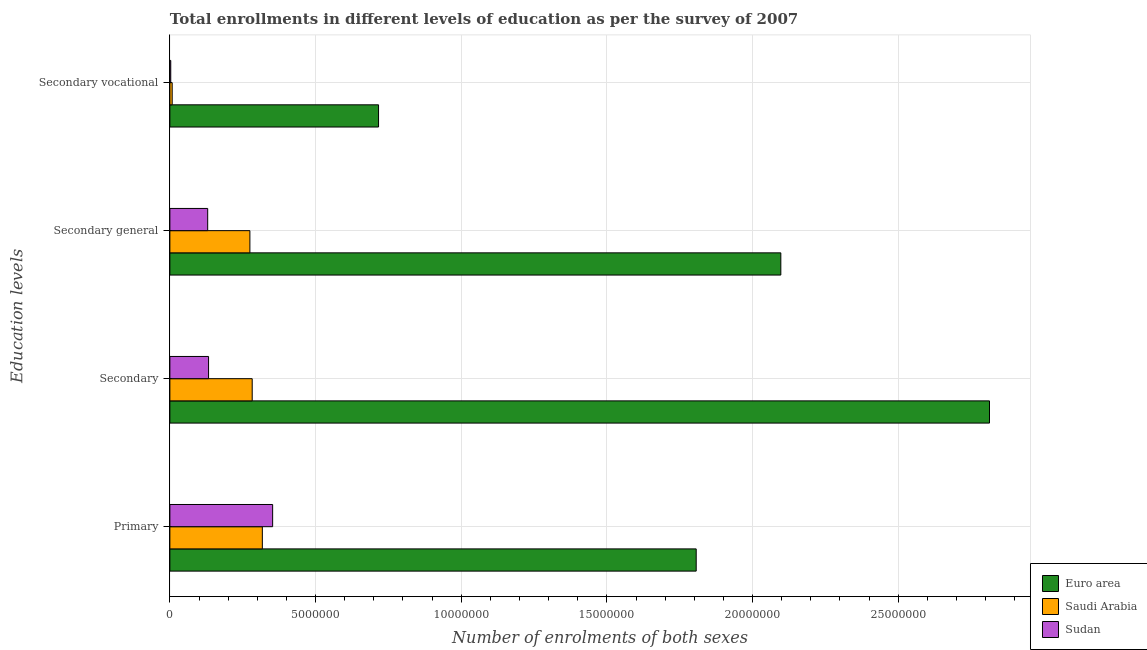How many different coloured bars are there?
Your response must be concise. 3. Are the number of bars per tick equal to the number of legend labels?
Ensure brevity in your answer.  Yes. What is the label of the 3rd group of bars from the top?
Offer a very short reply. Secondary. What is the number of enrolments in primary education in Sudan?
Provide a succinct answer. 3.53e+06. Across all countries, what is the maximum number of enrolments in secondary education?
Your answer should be compact. 2.81e+07. Across all countries, what is the minimum number of enrolments in secondary education?
Your response must be concise. 1.33e+06. In which country was the number of enrolments in primary education maximum?
Ensure brevity in your answer.  Euro area. In which country was the number of enrolments in secondary education minimum?
Your response must be concise. Sudan. What is the total number of enrolments in secondary education in the graph?
Offer a terse response. 3.23e+07. What is the difference between the number of enrolments in secondary general education in Euro area and that in Saudi Arabia?
Offer a very short reply. 1.82e+07. What is the difference between the number of enrolments in secondary general education in Saudi Arabia and the number of enrolments in primary education in Sudan?
Provide a succinct answer. -7.81e+05. What is the average number of enrolments in secondary vocational education per country?
Your answer should be very brief. 2.42e+06. What is the difference between the number of enrolments in secondary education and number of enrolments in secondary general education in Sudan?
Offer a very short reply. 3.03e+04. What is the ratio of the number of enrolments in secondary vocational education in Sudan to that in Saudi Arabia?
Provide a short and direct response. 0.38. Is the number of enrolments in secondary vocational education in Euro area less than that in Saudi Arabia?
Provide a succinct answer. No. What is the difference between the highest and the second highest number of enrolments in primary education?
Your answer should be compact. 1.45e+07. What is the difference between the highest and the lowest number of enrolments in secondary general education?
Make the answer very short. 1.97e+07. In how many countries, is the number of enrolments in secondary general education greater than the average number of enrolments in secondary general education taken over all countries?
Your answer should be compact. 1. Is the sum of the number of enrolments in secondary vocational education in Saudi Arabia and Euro area greater than the maximum number of enrolments in secondary general education across all countries?
Your response must be concise. No. Is it the case that in every country, the sum of the number of enrolments in secondary education and number of enrolments in secondary vocational education is greater than the sum of number of enrolments in primary education and number of enrolments in secondary general education?
Give a very brief answer. No. What does the 3rd bar from the top in Secondary represents?
Keep it short and to the point. Euro area. What does the 3rd bar from the bottom in Primary represents?
Offer a terse response. Sudan. Is it the case that in every country, the sum of the number of enrolments in primary education and number of enrolments in secondary education is greater than the number of enrolments in secondary general education?
Your response must be concise. Yes. Are all the bars in the graph horizontal?
Make the answer very short. Yes. What is the difference between two consecutive major ticks on the X-axis?
Your answer should be very brief. 5.00e+06. Are the values on the major ticks of X-axis written in scientific E-notation?
Offer a very short reply. No. Where does the legend appear in the graph?
Offer a terse response. Bottom right. How many legend labels are there?
Offer a very short reply. 3. How are the legend labels stacked?
Offer a terse response. Vertical. What is the title of the graph?
Provide a short and direct response. Total enrollments in different levels of education as per the survey of 2007. Does "Sweden" appear as one of the legend labels in the graph?
Keep it short and to the point. No. What is the label or title of the X-axis?
Ensure brevity in your answer.  Number of enrolments of both sexes. What is the label or title of the Y-axis?
Offer a terse response. Education levels. What is the Number of enrolments of both sexes in Euro area in Primary?
Offer a very short reply. 1.81e+07. What is the Number of enrolments of both sexes in Saudi Arabia in Primary?
Provide a short and direct response. 3.17e+06. What is the Number of enrolments of both sexes in Sudan in Primary?
Provide a short and direct response. 3.53e+06. What is the Number of enrolments of both sexes of Euro area in Secondary?
Your response must be concise. 2.81e+07. What is the Number of enrolments of both sexes in Saudi Arabia in Secondary?
Ensure brevity in your answer.  2.83e+06. What is the Number of enrolments of both sexes in Sudan in Secondary?
Ensure brevity in your answer.  1.33e+06. What is the Number of enrolments of both sexes of Euro area in Secondary general?
Ensure brevity in your answer.  2.10e+07. What is the Number of enrolments of both sexes of Saudi Arabia in Secondary general?
Your answer should be compact. 2.75e+06. What is the Number of enrolments of both sexes of Sudan in Secondary general?
Provide a short and direct response. 1.30e+06. What is the Number of enrolments of both sexes in Euro area in Secondary vocational?
Make the answer very short. 7.16e+06. What is the Number of enrolments of both sexes in Saudi Arabia in Secondary vocational?
Ensure brevity in your answer.  7.96e+04. What is the Number of enrolments of both sexes of Sudan in Secondary vocational?
Ensure brevity in your answer.  3.03e+04. Across all Education levels, what is the maximum Number of enrolments of both sexes of Euro area?
Your answer should be compact. 2.81e+07. Across all Education levels, what is the maximum Number of enrolments of both sexes in Saudi Arabia?
Ensure brevity in your answer.  3.17e+06. Across all Education levels, what is the maximum Number of enrolments of both sexes in Sudan?
Keep it short and to the point. 3.53e+06. Across all Education levels, what is the minimum Number of enrolments of both sexes of Euro area?
Ensure brevity in your answer.  7.16e+06. Across all Education levels, what is the minimum Number of enrolments of both sexes in Saudi Arabia?
Keep it short and to the point. 7.96e+04. Across all Education levels, what is the minimum Number of enrolments of both sexes in Sudan?
Provide a short and direct response. 3.03e+04. What is the total Number of enrolments of both sexes of Euro area in the graph?
Offer a very short reply. 7.43e+07. What is the total Number of enrolments of both sexes in Saudi Arabia in the graph?
Provide a succinct answer. 8.83e+06. What is the total Number of enrolments of both sexes in Sudan in the graph?
Your answer should be very brief. 6.18e+06. What is the difference between the Number of enrolments of both sexes in Euro area in Primary and that in Secondary?
Give a very brief answer. -1.01e+07. What is the difference between the Number of enrolments of both sexes in Saudi Arabia in Primary and that in Secondary?
Your answer should be very brief. 3.48e+05. What is the difference between the Number of enrolments of both sexes of Sudan in Primary and that in Secondary?
Offer a terse response. 2.20e+06. What is the difference between the Number of enrolments of both sexes in Euro area in Primary and that in Secondary general?
Make the answer very short. -2.90e+06. What is the difference between the Number of enrolments of both sexes in Saudi Arabia in Primary and that in Secondary general?
Give a very brief answer. 4.27e+05. What is the difference between the Number of enrolments of both sexes in Sudan in Primary and that in Secondary general?
Your answer should be compact. 2.23e+06. What is the difference between the Number of enrolments of both sexes in Euro area in Primary and that in Secondary vocational?
Your answer should be compact. 1.09e+07. What is the difference between the Number of enrolments of both sexes of Saudi Arabia in Primary and that in Secondary vocational?
Your answer should be very brief. 3.09e+06. What is the difference between the Number of enrolments of both sexes of Sudan in Primary and that in Secondary vocational?
Provide a succinct answer. 3.50e+06. What is the difference between the Number of enrolments of both sexes of Euro area in Secondary and that in Secondary general?
Your answer should be very brief. 7.16e+06. What is the difference between the Number of enrolments of both sexes in Saudi Arabia in Secondary and that in Secondary general?
Your response must be concise. 7.96e+04. What is the difference between the Number of enrolments of both sexes of Sudan in Secondary and that in Secondary general?
Provide a short and direct response. 3.03e+04. What is the difference between the Number of enrolments of both sexes of Euro area in Secondary and that in Secondary vocational?
Keep it short and to the point. 2.10e+07. What is the difference between the Number of enrolments of both sexes of Saudi Arabia in Secondary and that in Secondary vocational?
Your answer should be very brief. 2.75e+06. What is the difference between the Number of enrolments of both sexes in Sudan in Secondary and that in Secondary vocational?
Give a very brief answer. 1.30e+06. What is the difference between the Number of enrolments of both sexes in Euro area in Secondary general and that in Secondary vocational?
Offer a terse response. 1.38e+07. What is the difference between the Number of enrolments of both sexes of Saudi Arabia in Secondary general and that in Secondary vocational?
Ensure brevity in your answer.  2.67e+06. What is the difference between the Number of enrolments of both sexes of Sudan in Secondary general and that in Secondary vocational?
Your answer should be compact. 1.27e+06. What is the difference between the Number of enrolments of both sexes of Euro area in Primary and the Number of enrolments of both sexes of Saudi Arabia in Secondary?
Your answer should be compact. 1.52e+07. What is the difference between the Number of enrolments of both sexes of Euro area in Primary and the Number of enrolments of both sexes of Sudan in Secondary?
Your answer should be very brief. 1.67e+07. What is the difference between the Number of enrolments of both sexes in Saudi Arabia in Primary and the Number of enrolments of both sexes in Sudan in Secondary?
Offer a very short reply. 1.85e+06. What is the difference between the Number of enrolments of both sexes of Euro area in Primary and the Number of enrolments of both sexes of Saudi Arabia in Secondary general?
Provide a succinct answer. 1.53e+07. What is the difference between the Number of enrolments of both sexes in Euro area in Primary and the Number of enrolments of both sexes in Sudan in Secondary general?
Your answer should be compact. 1.68e+07. What is the difference between the Number of enrolments of both sexes in Saudi Arabia in Primary and the Number of enrolments of both sexes in Sudan in Secondary general?
Provide a short and direct response. 1.88e+06. What is the difference between the Number of enrolments of both sexes in Euro area in Primary and the Number of enrolments of both sexes in Saudi Arabia in Secondary vocational?
Keep it short and to the point. 1.80e+07. What is the difference between the Number of enrolments of both sexes in Euro area in Primary and the Number of enrolments of both sexes in Sudan in Secondary vocational?
Ensure brevity in your answer.  1.80e+07. What is the difference between the Number of enrolments of both sexes of Saudi Arabia in Primary and the Number of enrolments of both sexes of Sudan in Secondary vocational?
Ensure brevity in your answer.  3.14e+06. What is the difference between the Number of enrolments of both sexes of Euro area in Secondary and the Number of enrolments of both sexes of Saudi Arabia in Secondary general?
Your response must be concise. 2.54e+07. What is the difference between the Number of enrolments of both sexes of Euro area in Secondary and the Number of enrolments of both sexes of Sudan in Secondary general?
Your response must be concise. 2.68e+07. What is the difference between the Number of enrolments of both sexes in Saudi Arabia in Secondary and the Number of enrolments of both sexes in Sudan in Secondary general?
Offer a terse response. 1.53e+06. What is the difference between the Number of enrolments of both sexes of Euro area in Secondary and the Number of enrolments of both sexes of Saudi Arabia in Secondary vocational?
Make the answer very short. 2.81e+07. What is the difference between the Number of enrolments of both sexes in Euro area in Secondary and the Number of enrolments of both sexes in Sudan in Secondary vocational?
Your response must be concise. 2.81e+07. What is the difference between the Number of enrolments of both sexes of Saudi Arabia in Secondary and the Number of enrolments of both sexes of Sudan in Secondary vocational?
Keep it short and to the point. 2.80e+06. What is the difference between the Number of enrolments of both sexes of Euro area in Secondary general and the Number of enrolments of both sexes of Saudi Arabia in Secondary vocational?
Your answer should be compact. 2.09e+07. What is the difference between the Number of enrolments of both sexes in Euro area in Secondary general and the Number of enrolments of both sexes in Sudan in Secondary vocational?
Ensure brevity in your answer.  2.09e+07. What is the difference between the Number of enrolments of both sexes in Saudi Arabia in Secondary general and the Number of enrolments of both sexes in Sudan in Secondary vocational?
Provide a short and direct response. 2.72e+06. What is the average Number of enrolments of both sexes in Euro area per Education levels?
Offer a terse response. 1.86e+07. What is the average Number of enrolments of both sexes in Saudi Arabia per Education levels?
Make the answer very short. 2.21e+06. What is the average Number of enrolments of both sexes of Sudan per Education levels?
Your response must be concise. 1.55e+06. What is the difference between the Number of enrolments of both sexes of Euro area and Number of enrolments of both sexes of Saudi Arabia in Primary?
Offer a very short reply. 1.49e+07. What is the difference between the Number of enrolments of both sexes in Euro area and Number of enrolments of both sexes in Sudan in Primary?
Your response must be concise. 1.45e+07. What is the difference between the Number of enrolments of both sexes in Saudi Arabia and Number of enrolments of both sexes in Sudan in Primary?
Offer a terse response. -3.54e+05. What is the difference between the Number of enrolments of both sexes of Euro area and Number of enrolments of both sexes of Saudi Arabia in Secondary?
Provide a succinct answer. 2.53e+07. What is the difference between the Number of enrolments of both sexes in Euro area and Number of enrolments of both sexes in Sudan in Secondary?
Make the answer very short. 2.68e+07. What is the difference between the Number of enrolments of both sexes in Saudi Arabia and Number of enrolments of both sexes in Sudan in Secondary?
Your response must be concise. 1.50e+06. What is the difference between the Number of enrolments of both sexes of Euro area and Number of enrolments of both sexes of Saudi Arabia in Secondary general?
Your answer should be compact. 1.82e+07. What is the difference between the Number of enrolments of both sexes in Euro area and Number of enrolments of both sexes in Sudan in Secondary general?
Your response must be concise. 1.97e+07. What is the difference between the Number of enrolments of both sexes in Saudi Arabia and Number of enrolments of both sexes in Sudan in Secondary general?
Your answer should be compact. 1.45e+06. What is the difference between the Number of enrolments of both sexes of Euro area and Number of enrolments of both sexes of Saudi Arabia in Secondary vocational?
Give a very brief answer. 7.08e+06. What is the difference between the Number of enrolments of both sexes of Euro area and Number of enrolments of both sexes of Sudan in Secondary vocational?
Provide a short and direct response. 7.13e+06. What is the difference between the Number of enrolments of both sexes of Saudi Arabia and Number of enrolments of both sexes of Sudan in Secondary vocational?
Give a very brief answer. 4.93e+04. What is the ratio of the Number of enrolments of both sexes of Euro area in Primary to that in Secondary?
Your answer should be compact. 0.64. What is the ratio of the Number of enrolments of both sexes of Saudi Arabia in Primary to that in Secondary?
Make the answer very short. 1.12. What is the ratio of the Number of enrolments of both sexes of Sudan in Primary to that in Secondary?
Make the answer very short. 2.66. What is the ratio of the Number of enrolments of both sexes of Euro area in Primary to that in Secondary general?
Your answer should be compact. 0.86. What is the ratio of the Number of enrolments of both sexes in Saudi Arabia in Primary to that in Secondary general?
Offer a terse response. 1.16. What is the ratio of the Number of enrolments of both sexes in Sudan in Primary to that in Secondary general?
Ensure brevity in your answer.  2.72. What is the ratio of the Number of enrolments of both sexes in Euro area in Primary to that in Secondary vocational?
Your answer should be compact. 2.52. What is the ratio of the Number of enrolments of both sexes of Saudi Arabia in Primary to that in Secondary vocational?
Your response must be concise. 39.87. What is the ratio of the Number of enrolments of both sexes in Sudan in Primary to that in Secondary vocational?
Give a very brief answer. 116.55. What is the ratio of the Number of enrolments of both sexes of Euro area in Secondary to that in Secondary general?
Keep it short and to the point. 1.34. What is the ratio of the Number of enrolments of both sexes of Sudan in Secondary to that in Secondary general?
Your response must be concise. 1.02. What is the ratio of the Number of enrolments of both sexes in Euro area in Secondary to that in Secondary vocational?
Ensure brevity in your answer.  3.93. What is the ratio of the Number of enrolments of both sexes of Saudi Arabia in Secondary to that in Secondary vocational?
Ensure brevity in your answer.  35.5. What is the ratio of the Number of enrolments of both sexes in Sudan in Secondary to that in Secondary vocational?
Keep it short and to the point. 43.87. What is the ratio of the Number of enrolments of both sexes of Euro area in Secondary general to that in Secondary vocational?
Offer a very short reply. 2.93. What is the ratio of the Number of enrolments of both sexes of Saudi Arabia in Secondary general to that in Secondary vocational?
Offer a terse response. 34.5. What is the ratio of the Number of enrolments of both sexes in Sudan in Secondary general to that in Secondary vocational?
Provide a succinct answer. 42.87. What is the difference between the highest and the second highest Number of enrolments of both sexes of Euro area?
Give a very brief answer. 7.16e+06. What is the difference between the highest and the second highest Number of enrolments of both sexes in Saudi Arabia?
Offer a terse response. 3.48e+05. What is the difference between the highest and the second highest Number of enrolments of both sexes in Sudan?
Keep it short and to the point. 2.20e+06. What is the difference between the highest and the lowest Number of enrolments of both sexes of Euro area?
Make the answer very short. 2.10e+07. What is the difference between the highest and the lowest Number of enrolments of both sexes in Saudi Arabia?
Offer a very short reply. 3.09e+06. What is the difference between the highest and the lowest Number of enrolments of both sexes of Sudan?
Make the answer very short. 3.50e+06. 